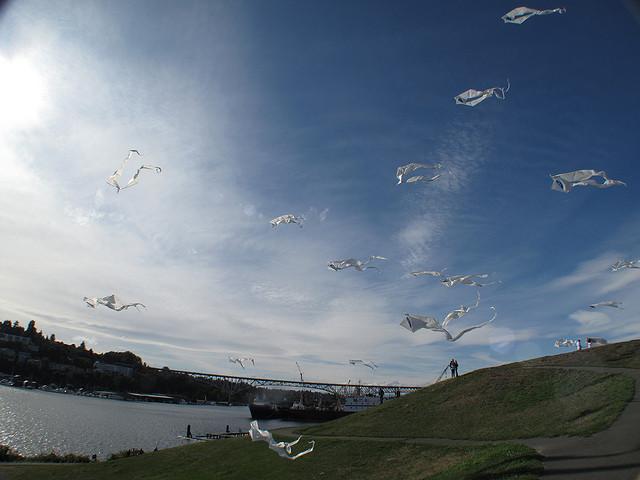How many kind of kite shapes available?
Select the accurate answer and provide justification: `Answer: choice
Rationale: srationale.`
Options: Eight, three, five, four. Answer: eight.
Rationale: There are eight kites in the sky. 